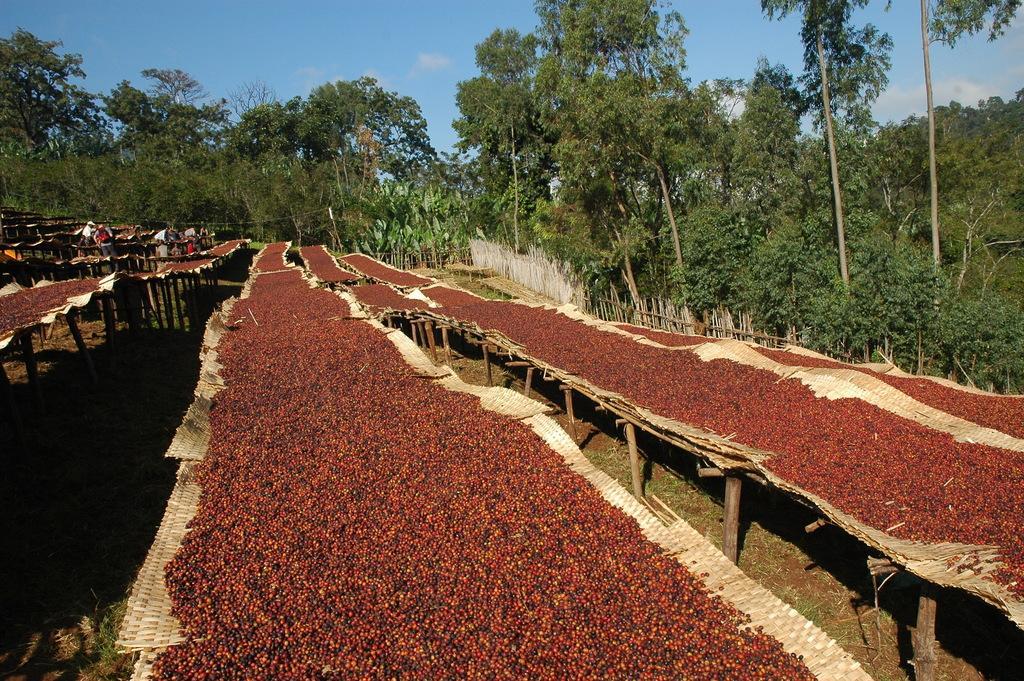In one or two sentences, can you explain what this image depicts? This image consists of many trees. At the top, there is sky. At the bottom, it looks like grains or seeds. At the bottom, there is ground. And we can see the green grass on the ground. There are few people in this image. 